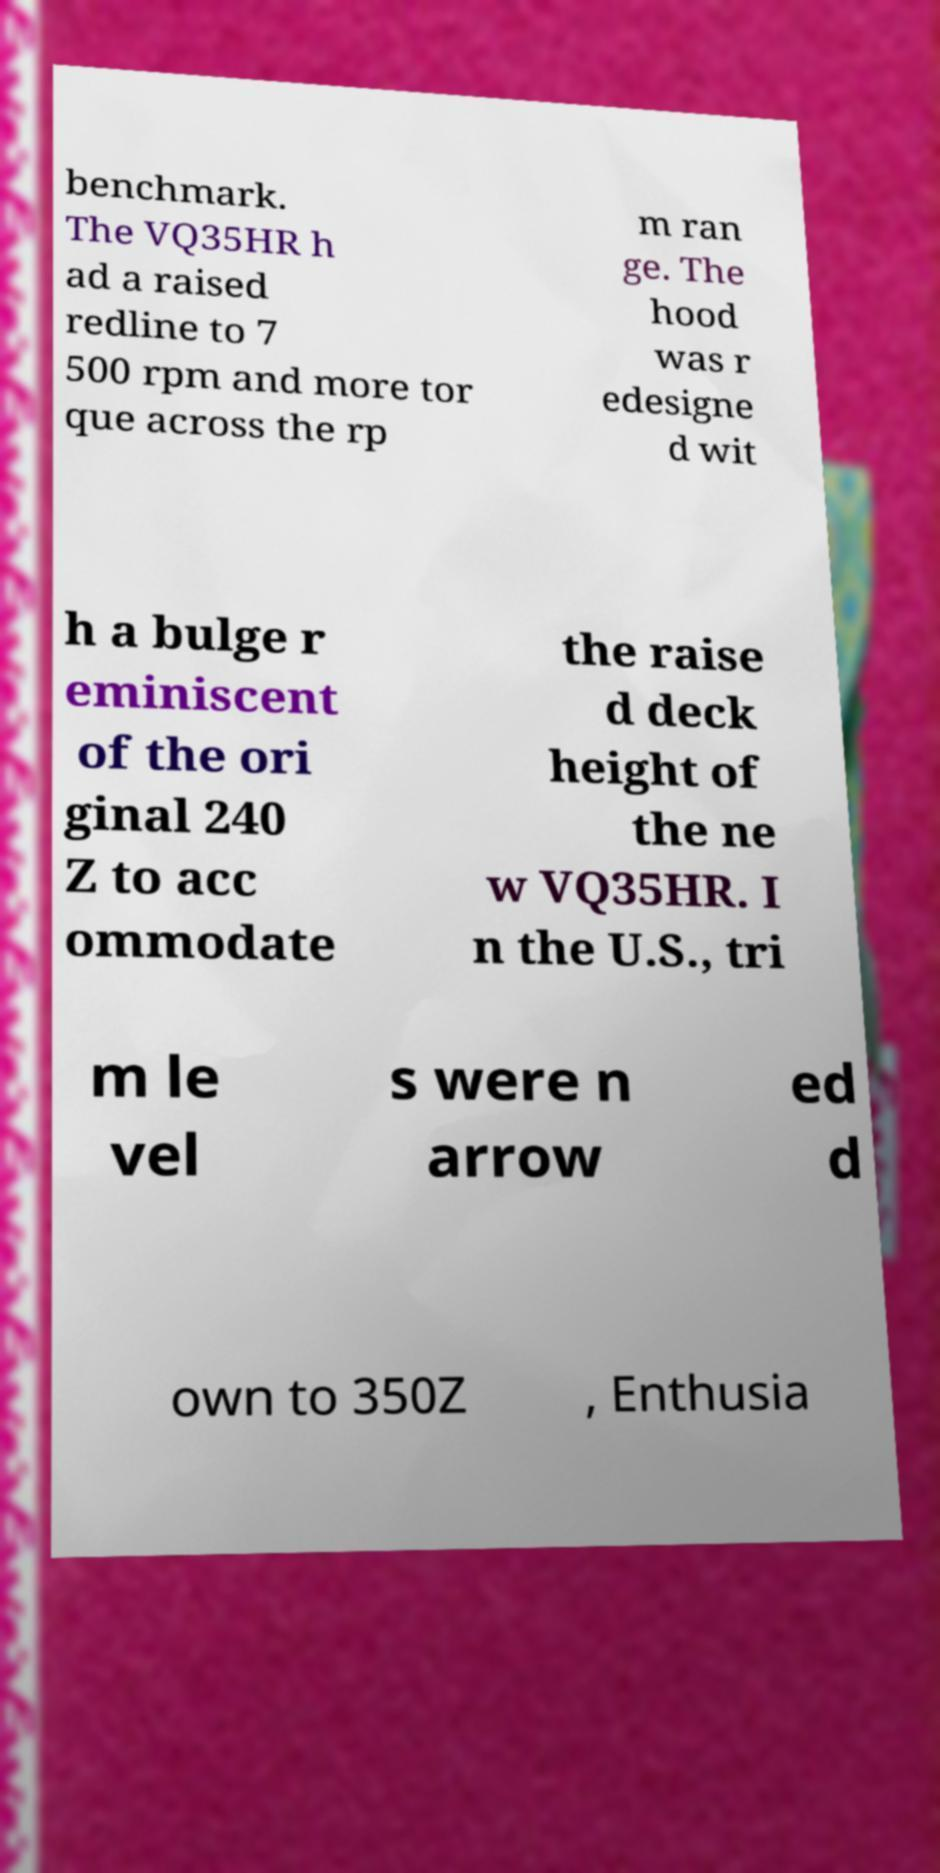Can you read and provide the text displayed in the image?This photo seems to have some interesting text. Can you extract and type it out for me? benchmark. The VQ35HR h ad a raised redline to 7 500 rpm and more tor que across the rp m ran ge. The hood was r edesigne d wit h a bulge r eminiscent of the ori ginal 240 Z to acc ommodate the raise d deck height of the ne w VQ35HR. I n the U.S., tri m le vel s were n arrow ed d own to 350Z , Enthusia 